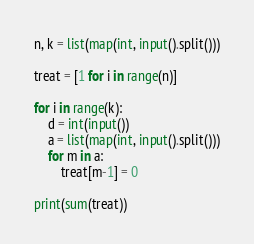Convert code to text. <code><loc_0><loc_0><loc_500><loc_500><_Python_>n, k = list(map(int, input().split()))

treat = [1 for i in range(n)]

for i in range(k):
    d = int(input())
    a = list(map(int, input().split()))
    for m in a:
        treat[m-1] = 0

print(sum(treat))</code> 